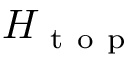<formula> <loc_0><loc_0><loc_500><loc_500>H _ { t o p }</formula> 